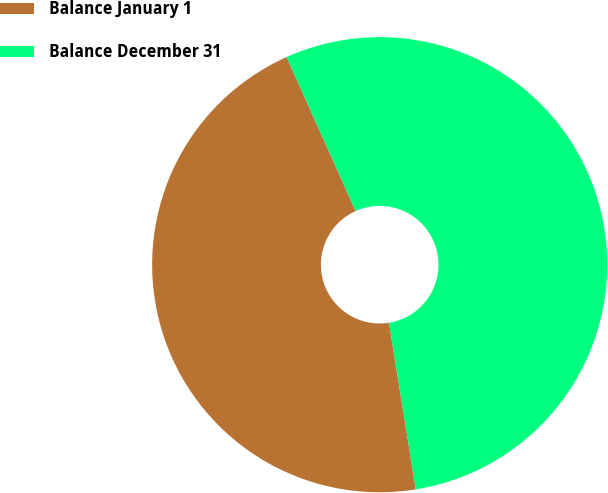Convert chart. <chart><loc_0><loc_0><loc_500><loc_500><pie_chart><fcel>Balance January 1<fcel>Balance December 31<nl><fcel>45.83%<fcel>54.17%<nl></chart> 